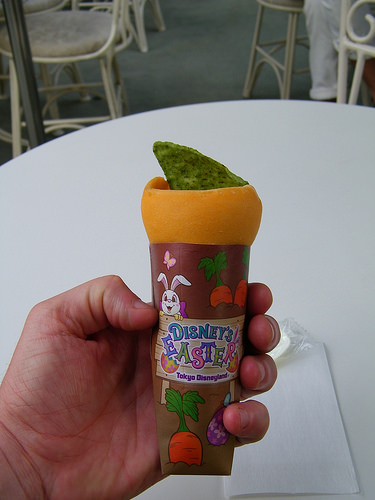<image>
Is there a palm next to the treat? Yes. The palm is positioned adjacent to the treat, located nearby in the same general area. 